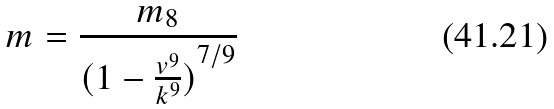<formula> <loc_0><loc_0><loc_500><loc_500>m = \frac { m _ { 8 } } { ( { 1 - \frac { v ^ { 9 } } { k ^ { 9 } } ) } ^ { 7 / 9 } }</formula> 